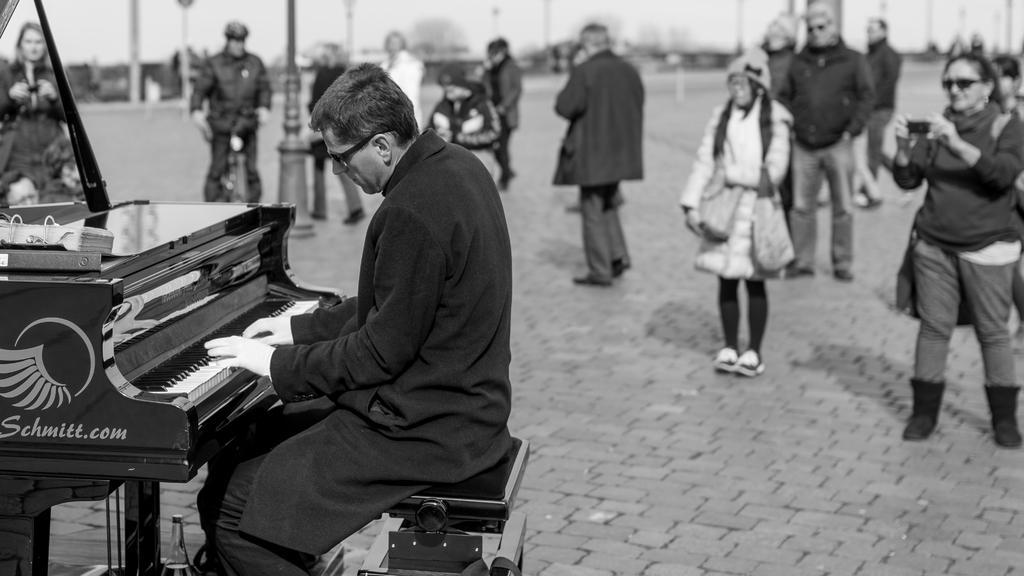In one or two sentences, can you explain what this image depicts? In the left side of the image, one person is sitting and playing a keyboard. In the background, there are group of people standing and watching instrument and a person. In the background top, sky visible of white in color and trees are visible. This image is taken during day time on the road. 